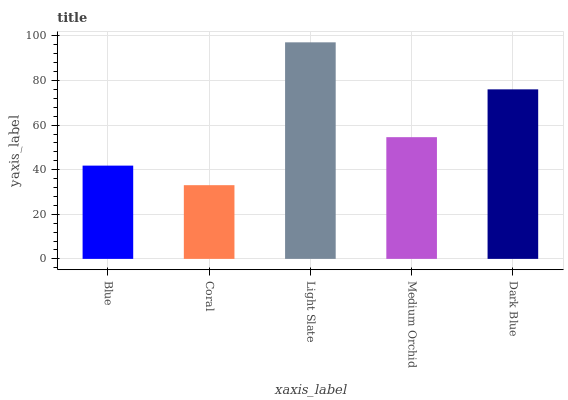Is Coral the minimum?
Answer yes or no. Yes. Is Light Slate the maximum?
Answer yes or no. Yes. Is Light Slate the minimum?
Answer yes or no. No. Is Coral the maximum?
Answer yes or no. No. Is Light Slate greater than Coral?
Answer yes or no. Yes. Is Coral less than Light Slate?
Answer yes or no. Yes. Is Coral greater than Light Slate?
Answer yes or no. No. Is Light Slate less than Coral?
Answer yes or no. No. Is Medium Orchid the high median?
Answer yes or no. Yes. Is Medium Orchid the low median?
Answer yes or no. Yes. Is Dark Blue the high median?
Answer yes or no. No. Is Light Slate the low median?
Answer yes or no. No. 